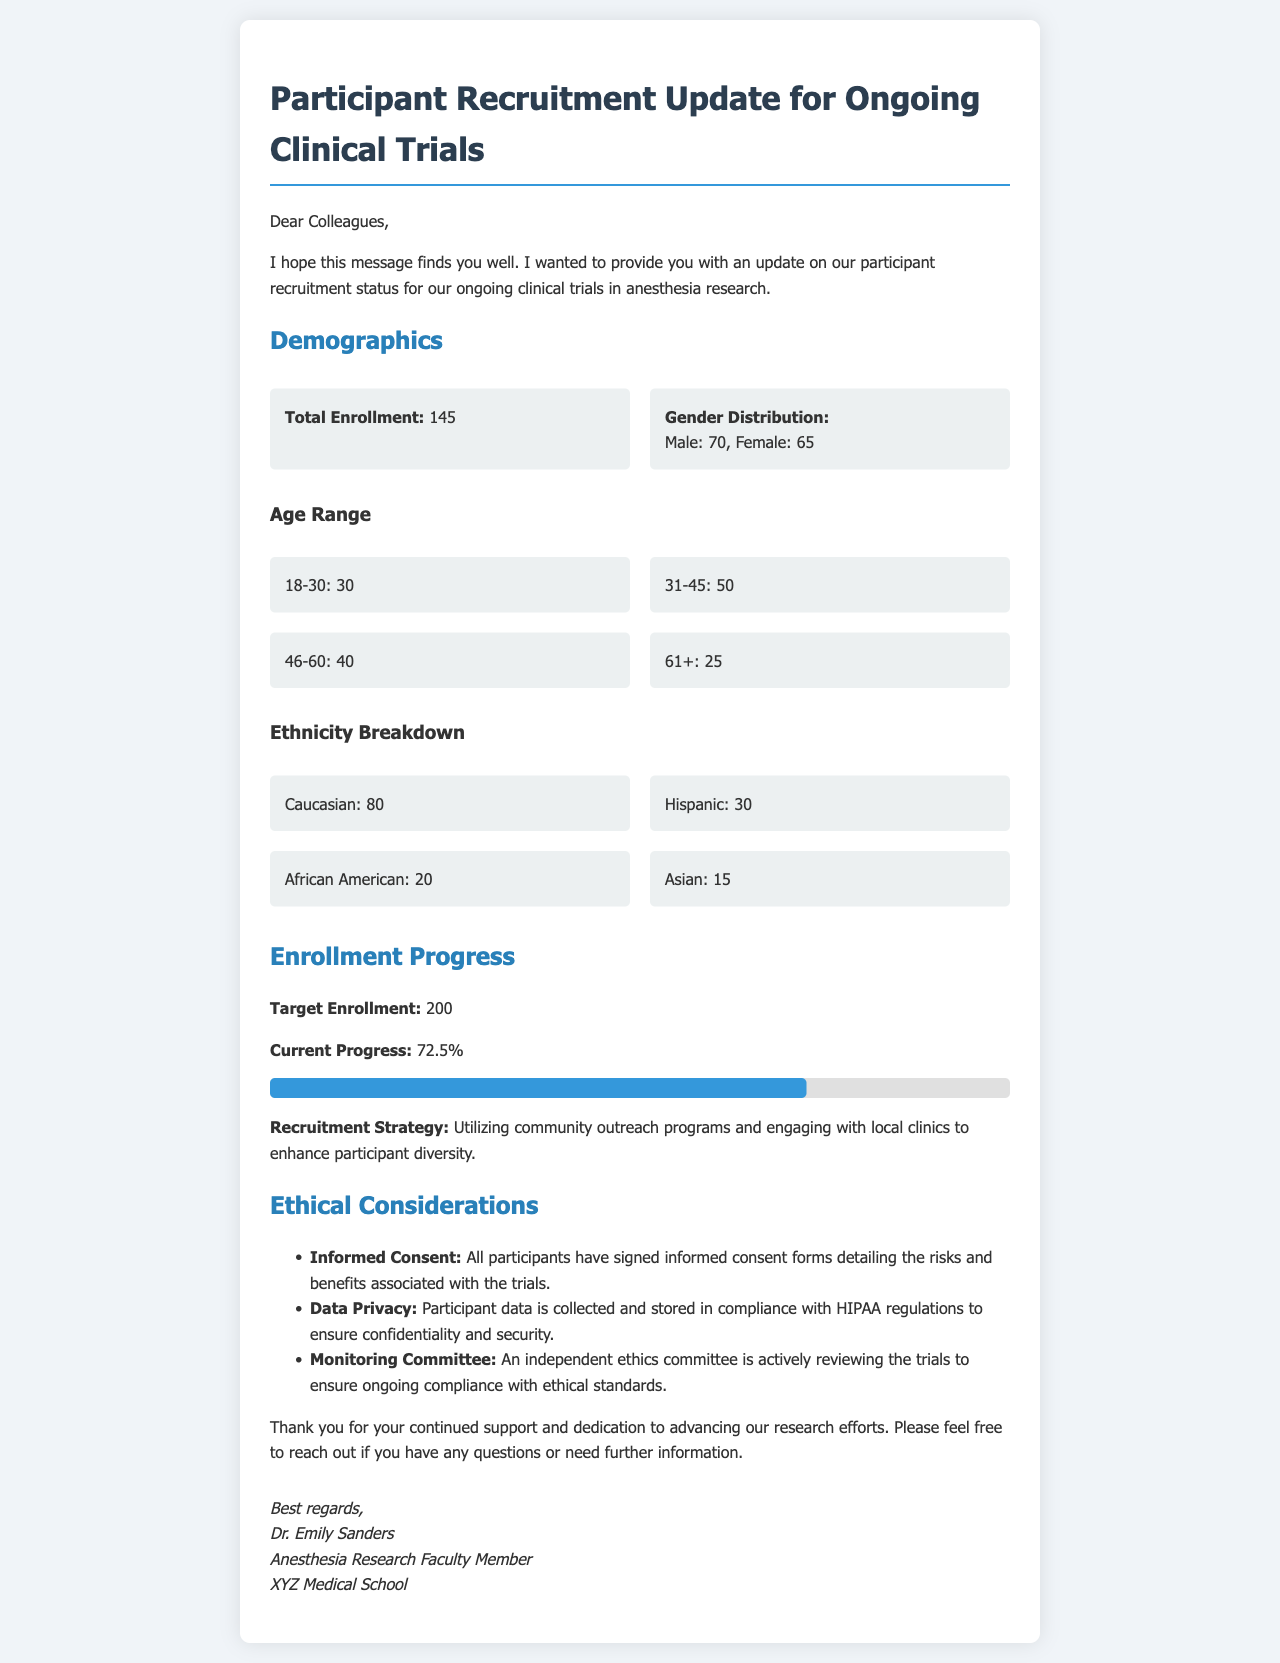What is the total enrollment? The total enrollment is stated as 145 participants in the document.
Answer: 145 What is the gender distribution? The document specifies the number of male and female participants, which is Male: 70, Female: 65.
Answer: Male: 70, Female: 65 What age group has the highest number of participants? The age group 31-45 has the highest enrollment with 50 participants.
Answer: 31-45 What is the target enrollment for the trials? The document mentions a target enrollment of 200 participants.
Answer: 200 What percentage of the target enrollment has been reached? The current progress is noted as 72.5% of the target enrollment.
Answer: 72.5% What is the recruitment strategy mentioned? The document states that the recruitment strategy involves utilizing community outreach programs and engaging with local clinics.
Answer: Community outreach programs and engaging with local clinics What ethical consideration ensures participant confidentiality? The document outlines that participant data is collected and stored in compliance with HIPAA regulations to ensure confidentiality.
Answer: HIPAA regulations Who is the sender of the email? The email is signed by Dr. Emily Sanders, who is a faculty member at the anesthesia research department.
Answer: Dr. Emily Sanders What is the role of the independent ethics committee? The ethics committee is actively reviewing the trials to ensure compliance with ethical standards.
Answer: Reviewing the trials for compliance with ethical standards 